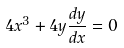<formula> <loc_0><loc_0><loc_500><loc_500>4 x ^ { 3 } + 4 y \frac { d y } { d x } = 0</formula> 